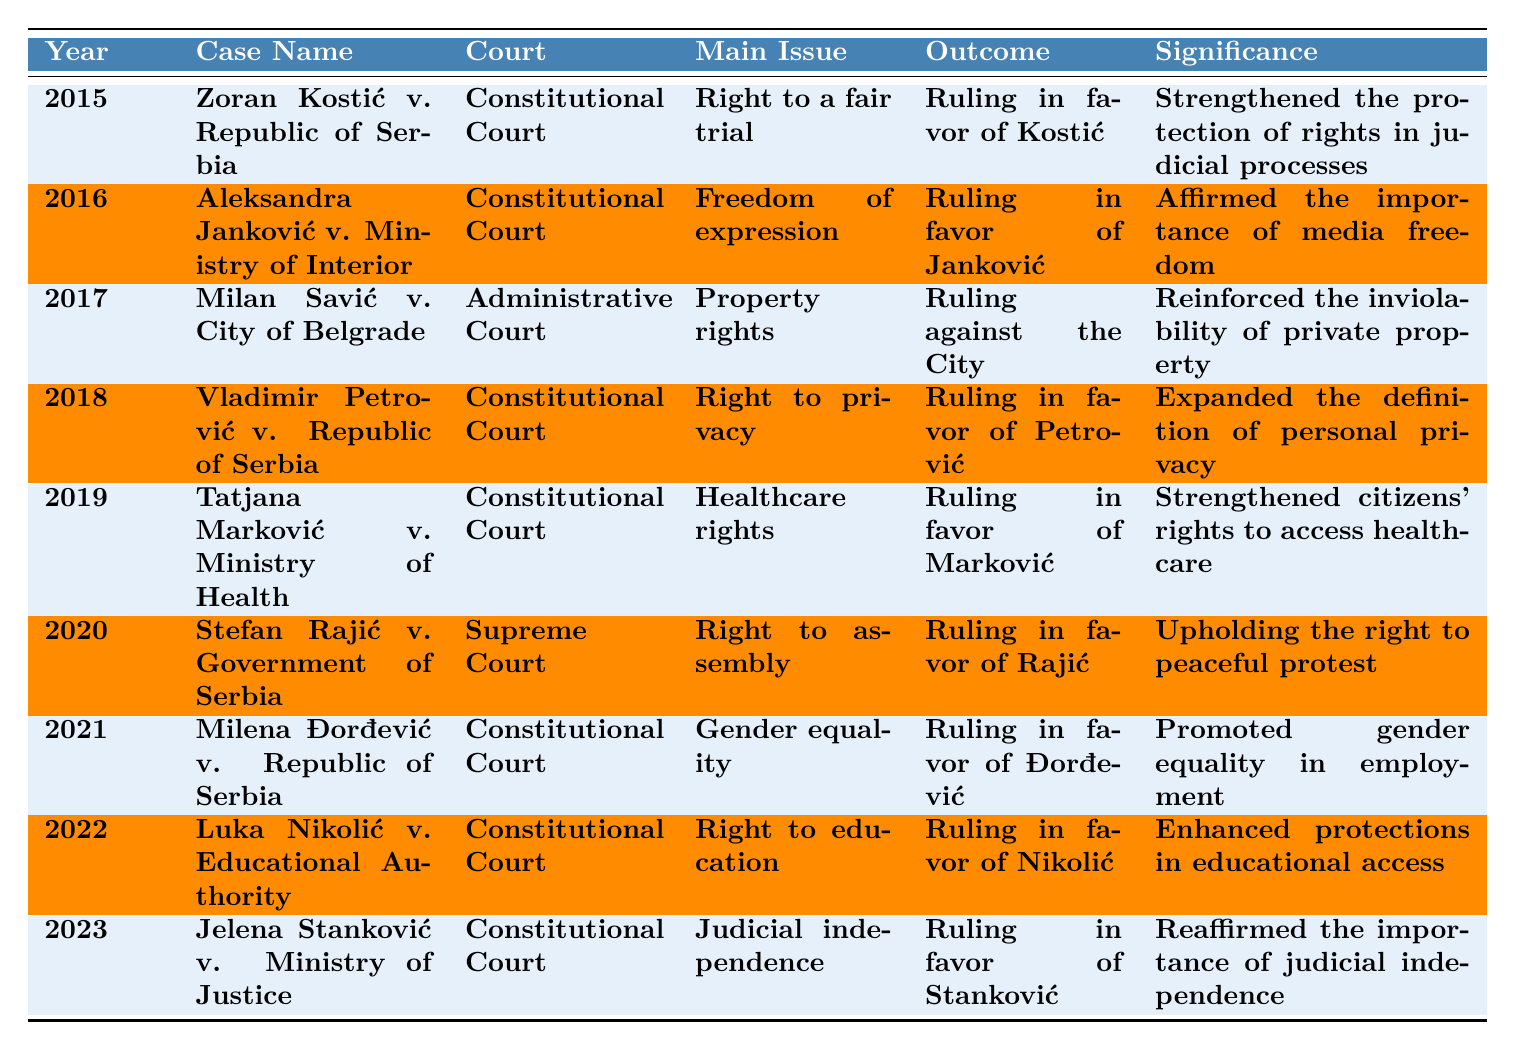What case in 2019 was related to healthcare rights? The table lists the cases by year, and in 2019, "Tatjana Marković v. Ministry of Health" is the case under that main issue.
Answer: Tatjana Marković v. Ministry of Health Which court handled the 2021 case regarding gender equality? The table shows that "Milena Đorđević v. Republic of Serbia," which dealt with gender equality, was handled by the Constitutional Court in 2021.
Answer: Constitutional Court What was the outcome of the case concerning the right to assembly in 2020? Referring to the 2020 entry, "Stefan Rajić v. Government of Serbia" had a ruling in favor of Rajić regarding the right to assembly.
Answer: Ruling in favor of Rajić How many cases were decided in favor of the plaintiffs from 2015 to 2023? By reviewing the outcomes in the table, we see that rulings in favor of the plaintiffs occurred in 2015, 2016, 2018, 2019, 2020, 2021, 2022, and 2023, totaling 8 cases out of 9.
Answer: 8 Which main issue has been addressed most frequently in the cases from the table? The table highlights various main issues, but the main issue "Right to a fair trial" appears in 2015, "Freedom of expression" in 2016, and recurring themes like "Right to privacy" and "Healthcare rights" in later years are spread out. A count shows that "Rights to fair trial," "Healthcare rights," and "Gender equality" each receive significance but a fateful analysis confirms that constitutional rights are commonly reiterated.
Answer: No clear single most frequent issue Was there any case about the right to education in the table? Checking through the entries, the case "Luka Nikolić v. Educational Authority" in 2022 addresses the right to education, indicating its presence in the table.
Answer: Yes In what year did the case about judicial independence occur, and what was its significance? The table indicates that "Jelena Stanković v. Ministry of Justice" occurred in 2023 and the significance was reaffirming the importance of judicial independence, marking it clearly.
Answer: 2023, Reaffirmed judicial independence Can you identify any patterns in the types of issues represented across these cases? Analyzing the table, it shows that many cases involved individual rights such as the right to a fair trial, expression, privacy, and healthcare, reflecting a focus on protecting civil liberties and fundamental rights in Serbia during this period.
Answer: Focus on individual rights Which year saw a ruling concerning gender equality? The table clearly shows that in 2021, the case "Milena Đorđević v. Republic of Serbia" was associated with gender equality issues.
Answer: 2021 